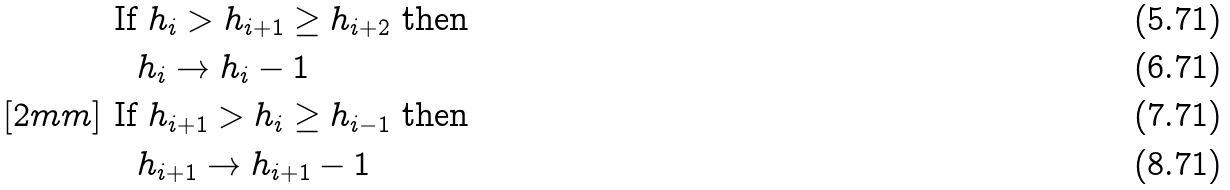<formula> <loc_0><loc_0><loc_500><loc_500>& \text { If } h _ { i } > h _ { i + 1 } \geq h _ { i + 2 } \text { then } \\ & \quad h _ { i } \to h _ { i } - 1 \\ [ 2 m m ] & \text { If } h _ { i + 1 } > h _ { i } \geq h _ { i - 1 } \text { then } \\ & \quad h _ { i + 1 } \to h _ { i + 1 } - 1</formula> 